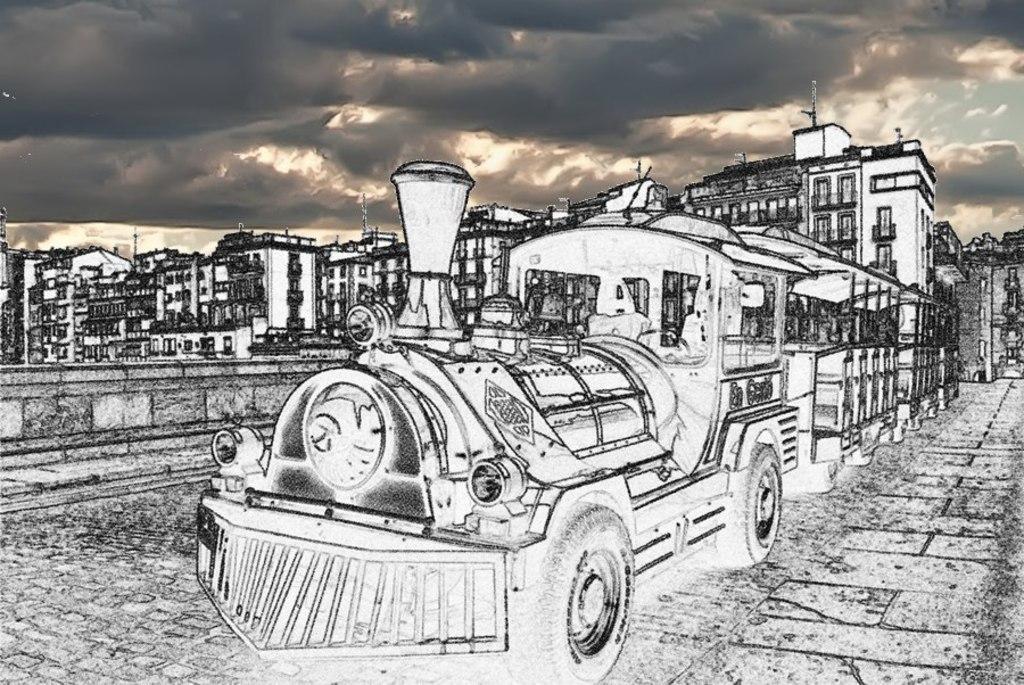Please provide a concise description of this image. This is an edited image. In front of the picture, we see the train. At the bottom, we see the pavement. There are buildings and poles in the background. At the top, we see the sky. 